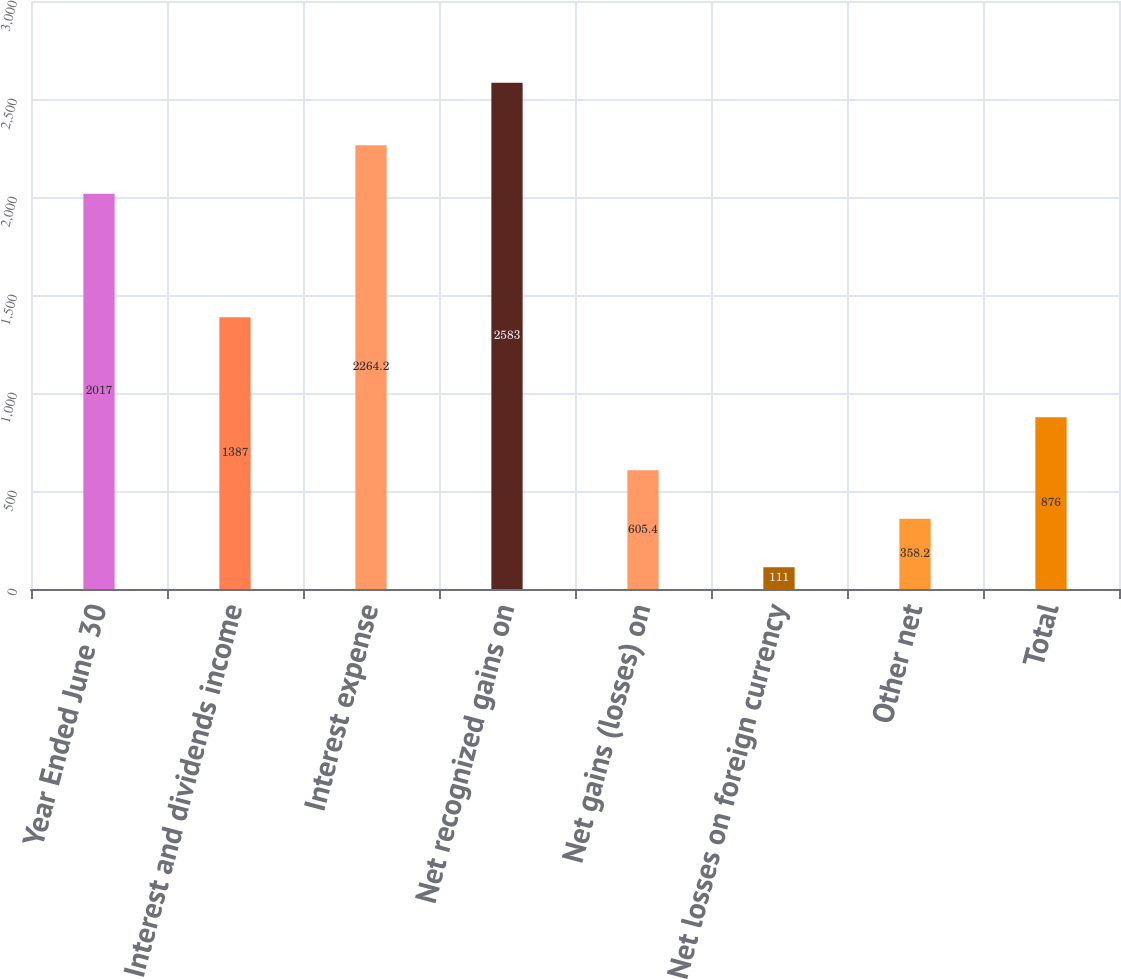Convert chart. <chart><loc_0><loc_0><loc_500><loc_500><bar_chart><fcel>Year Ended June 30<fcel>Interest and dividends income<fcel>Interest expense<fcel>Net recognized gains on<fcel>Net gains (losses) on<fcel>Net losses on foreign currency<fcel>Other net<fcel>Total<nl><fcel>2017<fcel>1387<fcel>2264.2<fcel>2583<fcel>605.4<fcel>111<fcel>358.2<fcel>876<nl></chart> 